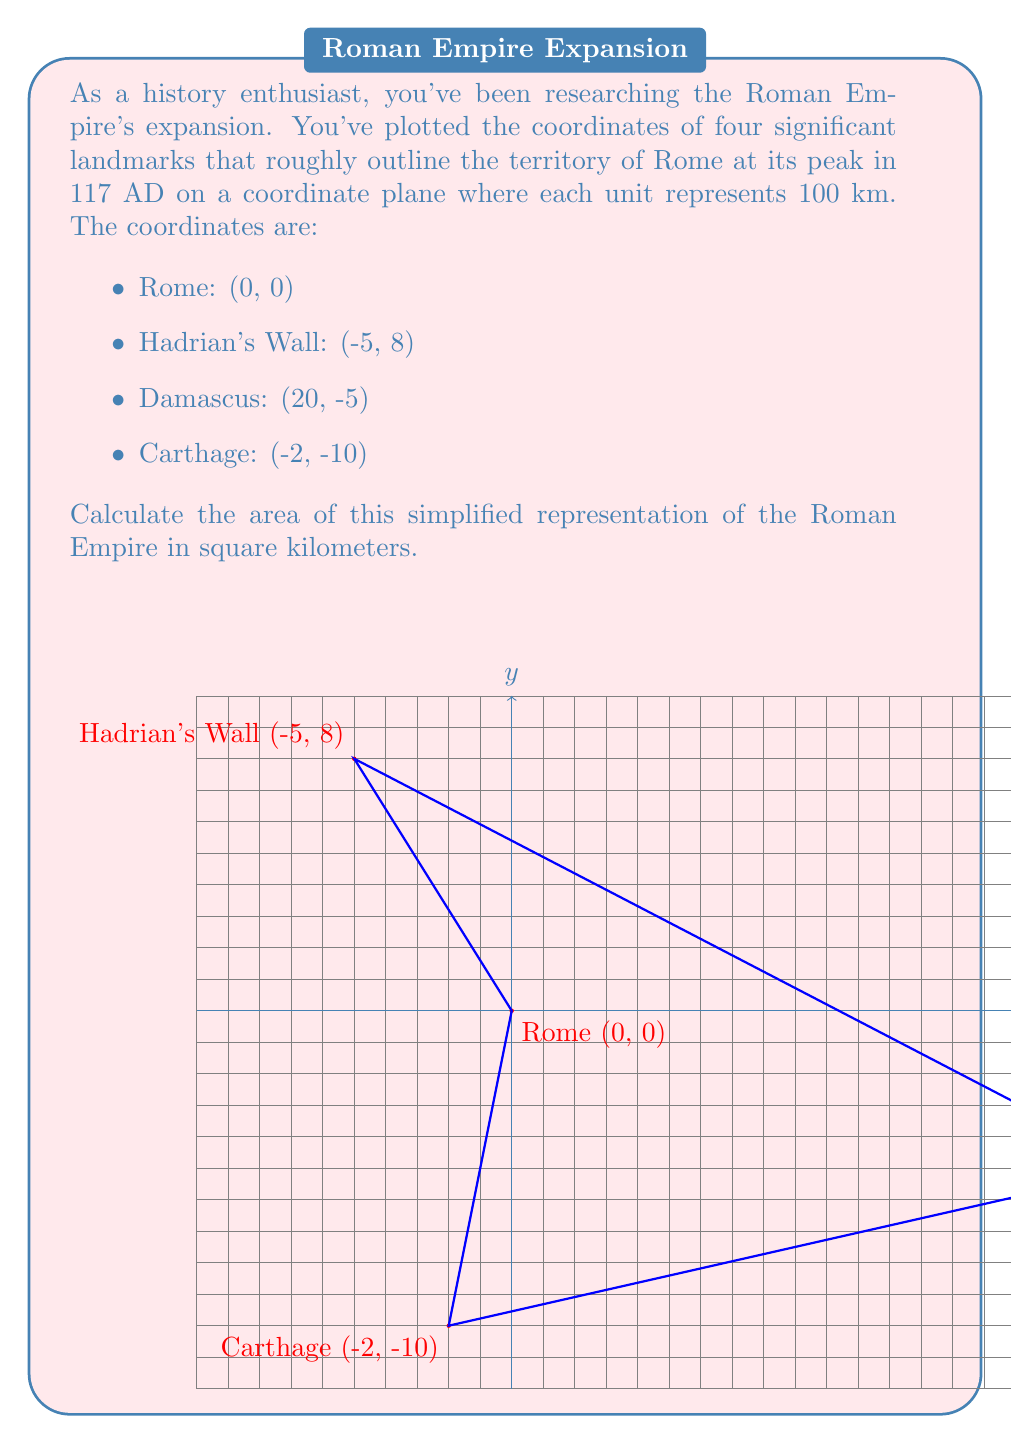Help me with this question. To solve this problem, we'll use the Shoelace formula (also known as the surveyor's formula) to calculate the area of the polygon formed by these points. The steps are as follows:

1) First, let's arrange the coordinates in order, either clockwise or counterclockwise:
   (0, 0), (-5, 8), (20, -5), (-2, -10)

2) The Shoelace formula is:

   $$Area = \frac{1}{2}|(x_1y_2 + x_2y_3 + x_3y_4 + x_4y_1) - (y_1x_2 + y_2x_3 + y_3x_4 + y_4x_1)|$$

3) Let's substitute our values:

   $$Area = \frac{1}{2}|(0 \cdot 8 + (-5) \cdot (-5) + 20 \cdot (-10) + (-2) \cdot 0) - (0 \cdot (-5) + 8 \cdot 20 + (-5) \cdot (-2) + (-10) \cdot 0)|$$

4) Simplify:

   $$Area = \frac{1}{2}|(0 + 25 - 200 + 0) - (0 + 160 + 10 + 0)|$$
   $$Area = \frac{1}{2}|(-175) - (170)|$$
   $$Area = \frac{1}{2}|-345|$$
   $$Area = \frac{345}{2} = 172.5$$

5) Remember that each unit represents 100 km, so we need to square this:

   $$Actual Area = 172.5 \cdot (100 km)^2 = 1,725,000 km^2$$

Therefore, the area of this simplified representation of the Roman Empire is 1,725,000 square kilometers.
Answer: 1,725,000 km² 